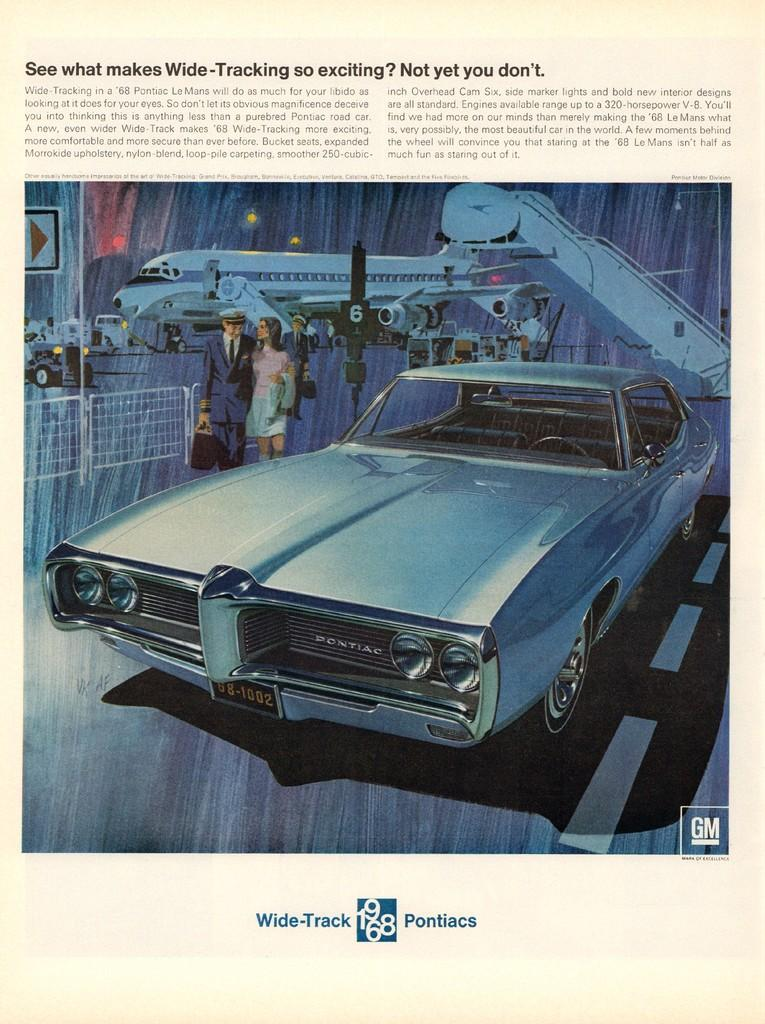What is the main subject of the document in the image? The document in the image contains pictures of an aeroplane, a car, a fence, persons, and a road. Can you describe the types of vehicles depicted in the document? The document contains pictures of an aeroplane and a car. What other elements are present in the document besides vehicles? The document also contains pictures of a fence, persons, and a road. What type of clam can be seen holding a pen and taking notes on the document in the image? There is no clam present in the image, and the document does not show anyone taking notes. 